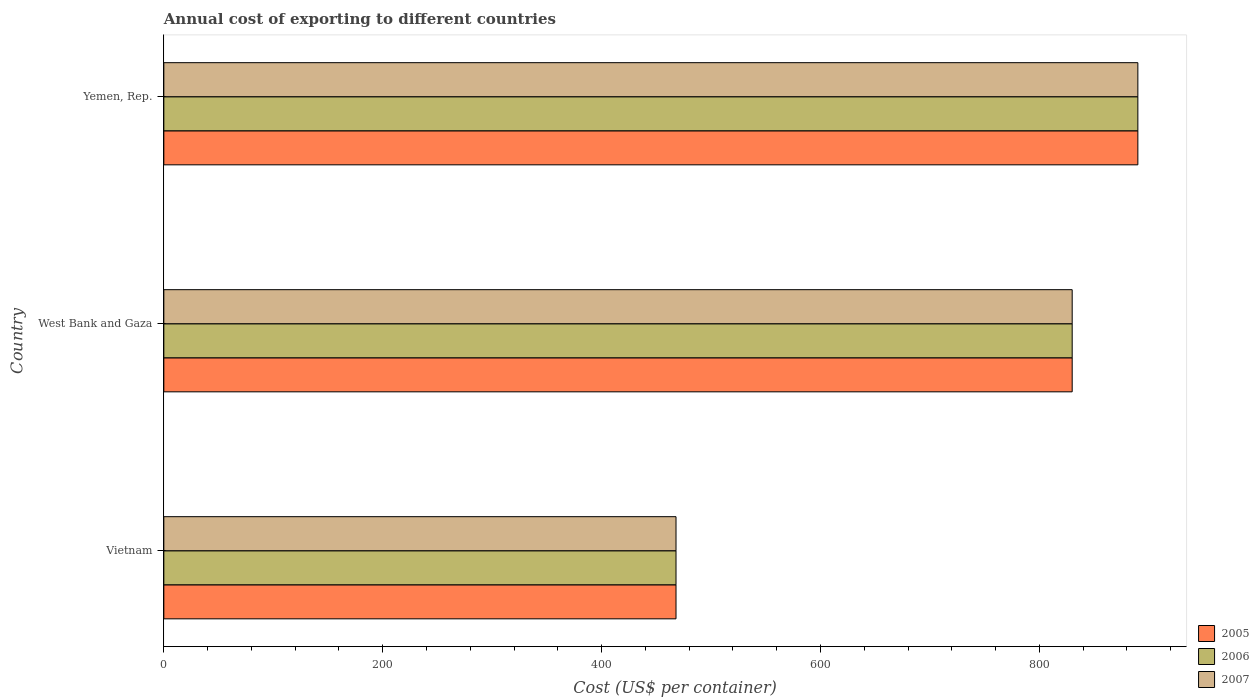How many groups of bars are there?
Keep it short and to the point. 3. Are the number of bars per tick equal to the number of legend labels?
Make the answer very short. Yes. Are the number of bars on each tick of the Y-axis equal?
Your response must be concise. Yes. How many bars are there on the 2nd tick from the top?
Your answer should be compact. 3. What is the label of the 1st group of bars from the top?
Keep it short and to the point. Yemen, Rep. In how many cases, is the number of bars for a given country not equal to the number of legend labels?
Give a very brief answer. 0. What is the total annual cost of exporting in 2006 in Vietnam?
Provide a short and direct response. 468. Across all countries, what is the maximum total annual cost of exporting in 2007?
Your response must be concise. 890. Across all countries, what is the minimum total annual cost of exporting in 2007?
Your response must be concise. 468. In which country was the total annual cost of exporting in 2007 maximum?
Offer a terse response. Yemen, Rep. In which country was the total annual cost of exporting in 2005 minimum?
Provide a short and direct response. Vietnam. What is the total total annual cost of exporting in 2007 in the graph?
Make the answer very short. 2188. What is the difference between the total annual cost of exporting in 2005 in Vietnam and that in Yemen, Rep.?
Provide a succinct answer. -422. What is the difference between the total annual cost of exporting in 2006 in West Bank and Gaza and the total annual cost of exporting in 2005 in Vietnam?
Provide a succinct answer. 362. What is the average total annual cost of exporting in 2005 per country?
Your response must be concise. 729.33. What is the ratio of the total annual cost of exporting in 2006 in Vietnam to that in Yemen, Rep.?
Offer a terse response. 0.53. Is the total annual cost of exporting in 2005 in Vietnam less than that in West Bank and Gaza?
Offer a terse response. Yes. Is the difference between the total annual cost of exporting in 2006 in Vietnam and Yemen, Rep. greater than the difference between the total annual cost of exporting in 2007 in Vietnam and Yemen, Rep.?
Ensure brevity in your answer.  No. What is the difference between the highest and the second highest total annual cost of exporting in 2006?
Keep it short and to the point. 60. What is the difference between the highest and the lowest total annual cost of exporting in 2005?
Your answer should be compact. 422. In how many countries, is the total annual cost of exporting in 2007 greater than the average total annual cost of exporting in 2007 taken over all countries?
Your response must be concise. 2. What does the 2nd bar from the bottom in West Bank and Gaza represents?
Your response must be concise. 2006. How many bars are there?
Offer a very short reply. 9. What is the difference between two consecutive major ticks on the X-axis?
Your response must be concise. 200. Does the graph contain any zero values?
Offer a very short reply. No. Does the graph contain grids?
Your answer should be very brief. No. Where does the legend appear in the graph?
Your response must be concise. Bottom right. How are the legend labels stacked?
Your answer should be compact. Vertical. What is the title of the graph?
Your answer should be very brief. Annual cost of exporting to different countries. Does "2008" appear as one of the legend labels in the graph?
Keep it short and to the point. No. What is the label or title of the X-axis?
Ensure brevity in your answer.  Cost (US$ per container). What is the Cost (US$ per container) in 2005 in Vietnam?
Offer a terse response. 468. What is the Cost (US$ per container) in 2006 in Vietnam?
Ensure brevity in your answer.  468. What is the Cost (US$ per container) of 2007 in Vietnam?
Offer a terse response. 468. What is the Cost (US$ per container) in 2005 in West Bank and Gaza?
Make the answer very short. 830. What is the Cost (US$ per container) in 2006 in West Bank and Gaza?
Provide a succinct answer. 830. What is the Cost (US$ per container) of 2007 in West Bank and Gaza?
Your answer should be very brief. 830. What is the Cost (US$ per container) in 2005 in Yemen, Rep.?
Give a very brief answer. 890. What is the Cost (US$ per container) in 2006 in Yemen, Rep.?
Make the answer very short. 890. What is the Cost (US$ per container) of 2007 in Yemen, Rep.?
Make the answer very short. 890. Across all countries, what is the maximum Cost (US$ per container) of 2005?
Make the answer very short. 890. Across all countries, what is the maximum Cost (US$ per container) in 2006?
Ensure brevity in your answer.  890. Across all countries, what is the maximum Cost (US$ per container) of 2007?
Provide a short and direct response. 890. Across all countries, what is the minimum Cost (US$ per container) of 2005?
Your response must be concise. 468. Across all countries, what is the minimum Cost (US$ per container) in 2006?
Ensure brevity in your answer.  468. Across all countries, what is the minimum Cost (US$ per container) in 2007?
Provide a short and direct response. 468. What is the total Cost (US$ per container) in 2005 in the graph?
Your response must be concise. 2188. What is the total Cost (US$ per container) of 2006 in the graph?
Your response must be concise. 2188. What is the total Cost (US$ per container) of 2007 in the graph?
Your answer should be very brief. 2188. What is the difference between the Cost (US$ per container) of 2005 in Vietnam and that in West Bank and Gaza?
Your answer should be compact. -362. What is the difference between the Cost (US$ per container) of 2006 in Vietnam and that in West Bank and Gaza?
Offer a terse response. -362. What is the difference between the Cost (US$ per container) in 2007 in Vietnam and that in West Bank and Gaza?
Your answer should be very brief. -362. What is the difference between the Cost (US$ per container) in 2005 in Vietnam and that in Yemen, Rep.?
Ensure brevity in your answer.  -422. What is the difference between the Cost (US$ per container) of 2006 in Vietnam and that in Yemen, Rep.?
Keep it short and to the point. -422. What is the difference between the Cost (US$ per container) in 2007 in Vietnam and that in Yemen, Rep.?
Your answer should be compact. -422. What is the difference between the Cost (US$ per container) in 2005 in West Bank and Gaza and that in Yemen, Rep.?
Your response must be concise. -60. What is the difference between the Cost (US$ per container) in 2006 in West Bank and Gaza and that in Yemen, Rep.?
Provide a short and direct response. -60. What is the difference between the Cost (US$ per container) in 2007 in West Bank and Gaza and that in Yemen, Rep.?
Your answer should be compact. -60. What is the difference between the Cost (US$ per container) in 2005 in Vietnam and the Cost (US$ per container) in 2006 in West Bank and Gaza?
Offer a terse response. -362. What is the difference between the Cost (US$ per container) in 2005 in Vietnam and the Cost (US$ per container) in 2007 in West Bank and Gaza?
Your answer should be very brief. -362. What is the difference between the Cost (US$ per container) of 2006 in Vietnam and the Cost (US$ per container) of 2007 in West Bank and Gaza?
Give a very brief answer. -362. What is the difference between the Cost (US$ per container) in 2005 in Vietnam and the Cost (US$ per container) in 2006 in Yemen, Rep.?
Offer a terse response. -422. What is the difference between the Cost (US$ per container) in 2005 in Vietnam and the Cost (US$ per container) in 2007 in Yemen, Rep.?
Provide a short and direct response. -422. What is the difference between the Cost (US$ per container) in 2006 in Vietnam and the Cost (US$ per container) in 2007 in Yemen, Rep.?
Your response must be concise. -422. What is the difference between the Cost (US$ per container) in 2005 in West Bank and Gaza and the Cost (US$ per container) in 2006 in Yemen, Rep.?
Make the answer very short. -60. What is the difference between the Cost (US$ per container) in 2005 in West Bank and Gaza and the Cost (US$ per container) in 2007 in Yemen, Rep.?
Offer a very short reply. -60. What is the difference between the Cost (US$ per container) in 2006 in West Bank and Gaza and the Cost (US$ per container) in 2007 in Yemen, Rep.?
Make the answer very short. -60. What is the average Cost (US$ per container) of 2005 per country?
Offer a very short reply. 729.33. What is the average Cost (US$ per container) of 2006 per country?
Offer a very short reply. 729.33. What is the average Cost (US$ per container) in 2007 per country?
Make the answer very short. 729.33. What is the difference between the Cost (US$ per container) in 2005 and Cost (US$ per container) in 2006 in West Bank and Gaza?
Give a very brief answer. 0. What is the difference between the Cost (US$ per container) of 2005 and Cost (US$ per container) of 2007 in West Bank and Gaza?
Offer a terse response. 0. What is the difference between the Cost (US$ per container) in 2005 and Cost (US$ per container) in 2006 in Yemen, Rep.?
Ensure brevity in your answer.  0. What is the difference between the Cost (US$ per container) of 2005 and Cost (US$ per container) of 2007 in Yemen, Rep.?
Offer a very short reply. 0. What is the difference between the Cost (US$ per container) of 2006 and Cost (US$ per container) of 2007 in Yemen, Rep.?
Keep it short and to the point. 0. What is the ratio of the Cost (US$ per container) in 2005 in Vietnam to that in West Bank and Gaza?
Your answer should be compact. 0.56. What is the ratio of the Cost (US$ per container) in 2006 in Vietnam to that in West Bank and Gaza?
Your answer should be very brief. 0.56. What is the ratio of the Cost (US$ per container) of 2007 in Vietnam to that in West Bank and Gaza?
Provide a short and direct response. 0.56. What is the ratio of the Cost (US$ per container) in 2005 in Vietnam to that in Yemen, Rep.?
Provide a short and direct response. 0.53. What is the ratio of the Cost (US$ per container) of 2006 in Vietnam to that in Yemen, Rep.?
Give a very brief answer. 0.53. What is the ratio of the Cost (US$ per container) in 2007 in Vietnam to that in Yemen, Rep.?
Your response must be concise. 0.53. What is the ratio of the Cost (US$ per container) of 2005 in West Bank and Gaza to that in Yemen, Rep.?
Your answer should be very brief. 0.93. What is the ratio of the Cost (US$ per container) of 2006 in West Bank and Gaza to that in Yemen, Rep.?
Make the answer very short. 0.93. What is the ratio of the Cost (US$ per container) of 2007 in West Bank and Gaza to that in Yemen, Rep.?
Offer a terse response. 0.93. What is the difference between the highest and the second highest Cost (US$ per container) in 2006?
Provide a short and direct response. 60. What is the difference between the highest and the lowest Cost (US$ per container) of 2005?
Ensure brevity in your answer.  422. What is the difference between the highest and the lowest Cost (US$ per container) in 2006?
Your answer should be compact. 422. What is the difference between the highest and the lowest Cost (US$ per container) in 2007?
Your response must be concise. 422. 